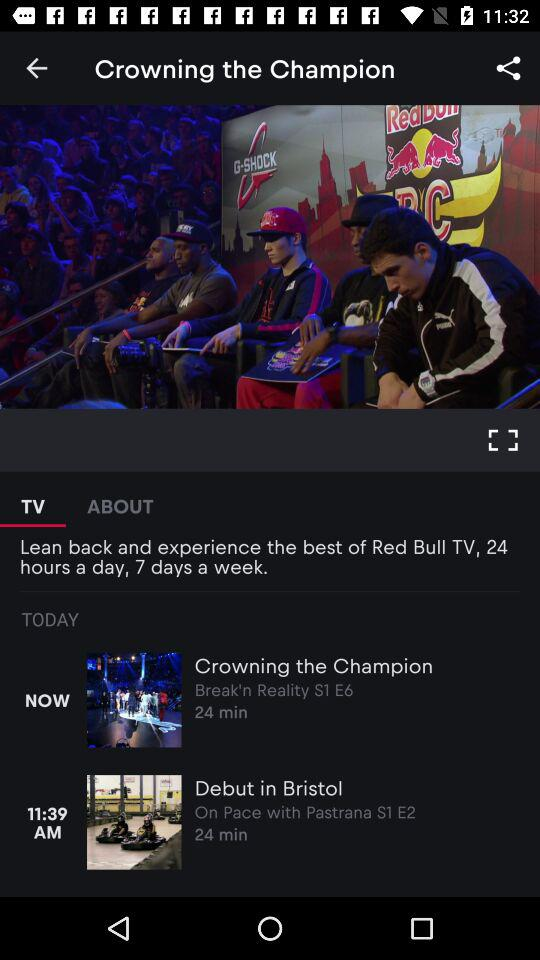What is the channel name of Crowning the champion?
When the provided information is insufficient, respond with <no answer>. <no answer> 